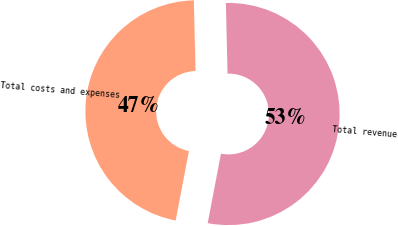Convert chart. <chart><loc_0><loc_0><loc_500><loc_500><pie_chart><fcel>Total revenue<fcel>Total costs and expenses<nl><fcel>53.38%<fcel>46.62%<nl></chart> 